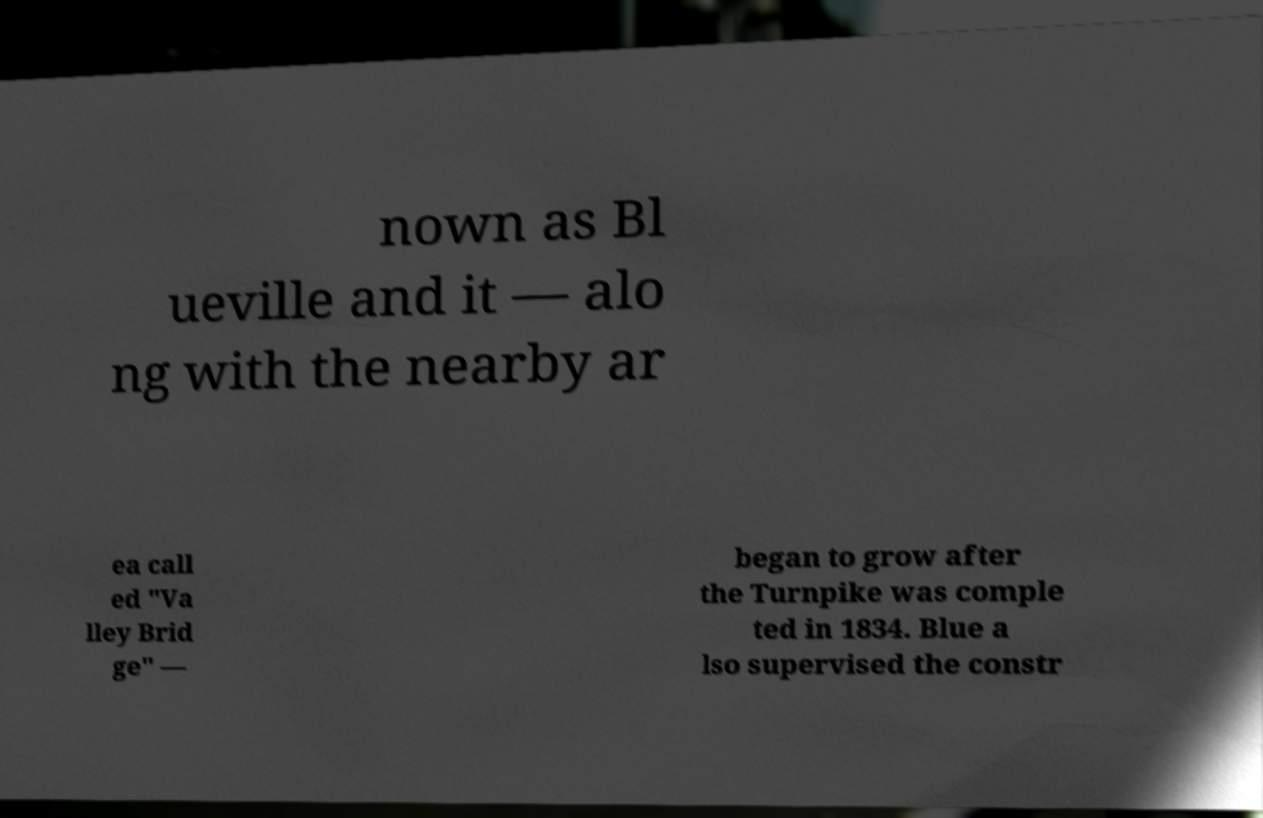Can you read and provide the text displayed in the image?This photo seems to have some interesting text. Can you extract and type it out for me? nown as Bl ueville and it — alo ng with the nearby ar ea call ed "Va lley Brid ge" — began to grow after the Turnpike was comple ted in 1834. Blue a lso supervised the constr 